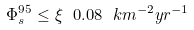<formula> <loc_0><loc_0><loc_500><loc_500>\Phi _ { s } ^ { 9 5 } \leq \xi \ 0 . 0 8 \ k m ^ { - 2 } y r ^ { - 1 }</formula> 